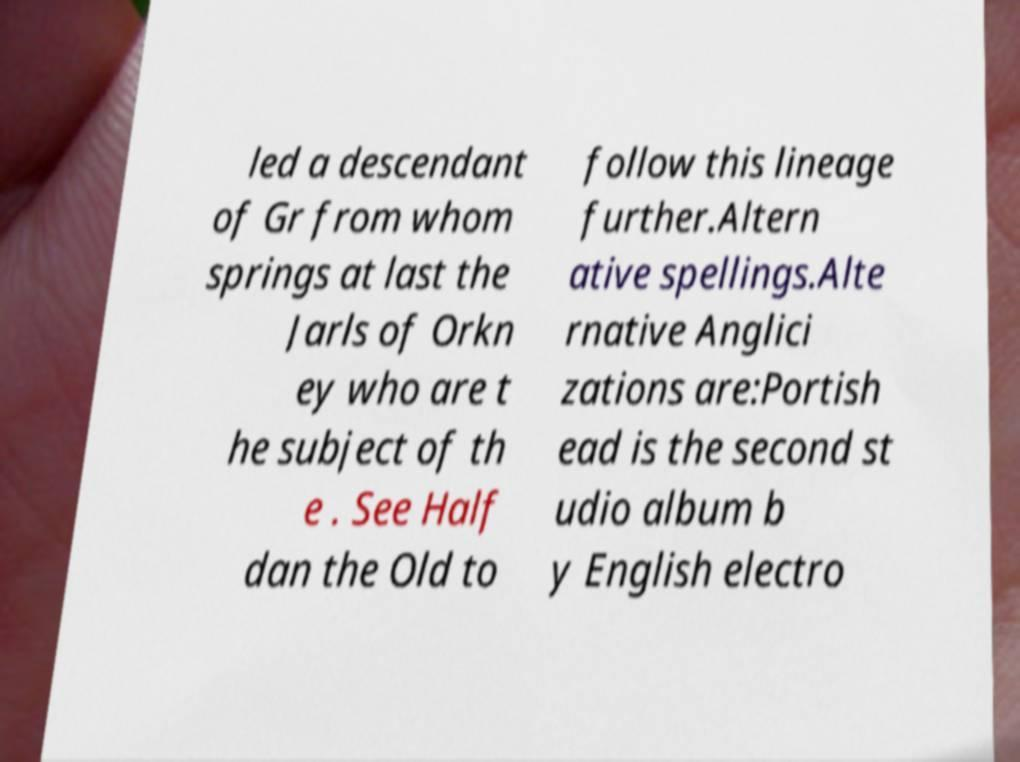Could you assist in decoding the text presented in this image and type it out clearly? led a descendant of Gr from whom springs at last the Jarls of Orkn ey who are t he subject of th e . See Half dan the Old to follow this lineage further.Altern ative spellings.Alte rnative Anglici zations are:Portish ead is the second st udio album b y English electro 